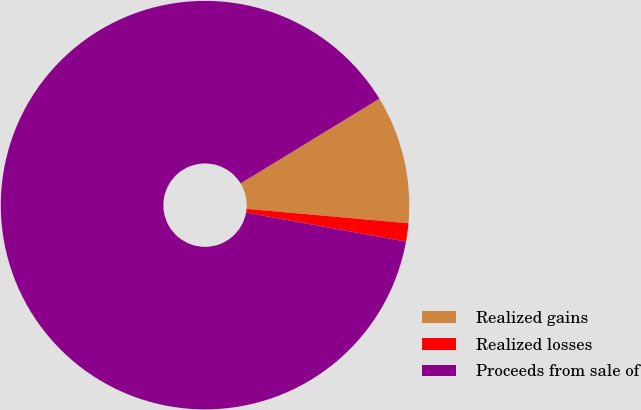Convert chart. <chart><loc_0><loc_0><loc_500><loc_500><pie_chart><fcel>Realized gains<fcel>Realized losses<fcel>Proceeds from sale of<nl><fcel>10.14%<fcel>1.44%<fcel>88.42%<nl></chart> 